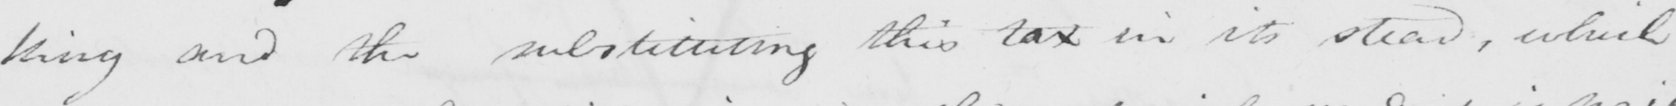Can you read and transcribe this handwriting? King and the substituting this tax in its stead , which 